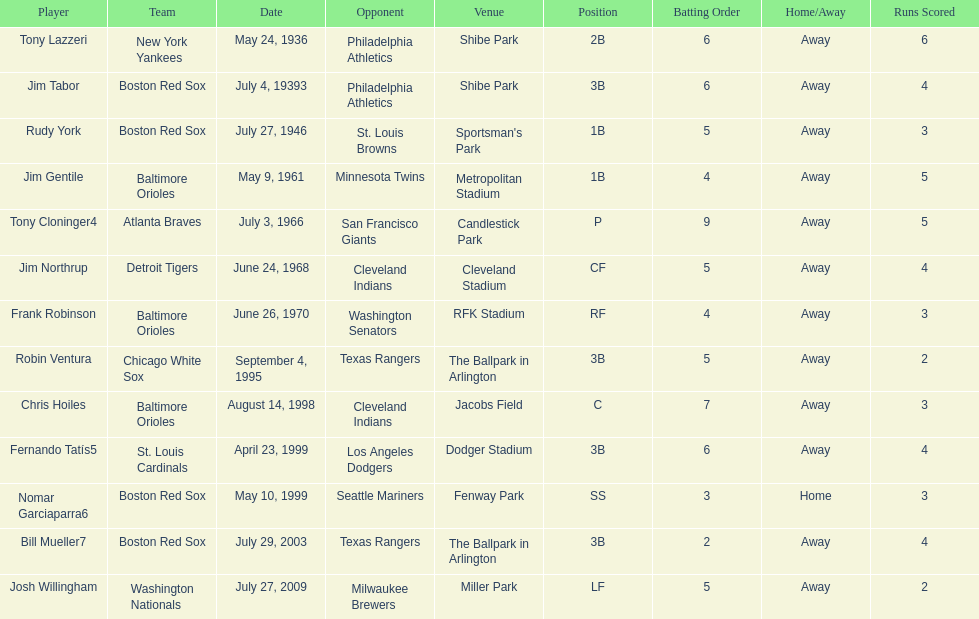In how many games has a boston red sox player achieved two grand slams? 4. Write the full table. {'header': ['Player', 'Team', 'Date', 'Opponent', 'Venue', 'Position', 'Batting Order', 'Home/Away', 'Runs Scored'], 'rows': [['Tony Lazzeri', 'New York Yankees', 'May 24, 1936', 'Philadelphia Athletics', 'Shibe Park', '2B', '6', 'Away', '6'], ['Jim Tabor', 'Boston Red Sox', 'July 4, 19393', 'Philadelphia Athletics', 'Shibe Park', '3B', '6', 'Away', '4'], ['Rudy York', 'Boston Red Sox', 'July 27, 1946', 'St. Louis Browns', "Sportsman's Park", '1B', '5', 'Away', '3'], ['Jim Gentile', 'Baltimore Orioles', 'May 9, 1961', 'Minnesota Twins', 'Metropolitan Stadium', '1B', '4', 'Away', '5'], ['Tony Cloninger4', 'Atlanta Braves', 'July 3, 1966', 'San Francisco Giants', 'Candlestick Park', 'P', '9', 'Away', '5'], ['Jim Northrup', 'Detroit Tigers', 'June 24, 1968', 'Cleveland Indians', 'Cleveland Stadium', 'CF', '5', 'Away', '4'], ['Frank Robinson', 'Baltimore Orioles', 'June 26, 1970', 'Washington Senators', 'RFK Stadium', 'RF', '4', 'Away', '3'], ['Robin Ventura', 'Chicago White Sox', 'September 4, 1995', 'Texas Rangers', 'The Ballpark in Arlington', '3B', '5', 'Away', '2'], ['Chris Hoiles', 'Baltimore Orioles', 'August 14, 1998', 'Cleveland Indians', 'Jacobs Field', 'C', '7', 'Away', '3'], ['Fernando Tatís5', 'St. Louis Cardinals', 'April 23, 1999', 'Los Angeles Dodgers', 'Dodger Stadium', '3B', '6', 'Away', '4'], ['Nomar Garciaparra6', 'Boston Red Sox', 'May 10, 1999', 'Seattle Mariners', 'Fenway Park', 'SS', '3', 'Home', '3'], ['Bill Mueller7', 'Boston Red Sox', 'July 29, 2003', 'Texas Rangers', 'The Ballpark in Arlington', '3B', '2', 'Away', '4'], ['Josh Willingham', 'Washington Nationals', 'July 27, 2009', 'Milwaukee Brewers', 'Miller Park', 'LF', '5', 'Away', '2']]} 